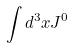<formula> <loc_0><loc_0><loc_500><loc_500>\int d ^ { 3 } x J ^ { 0 }</formula> 